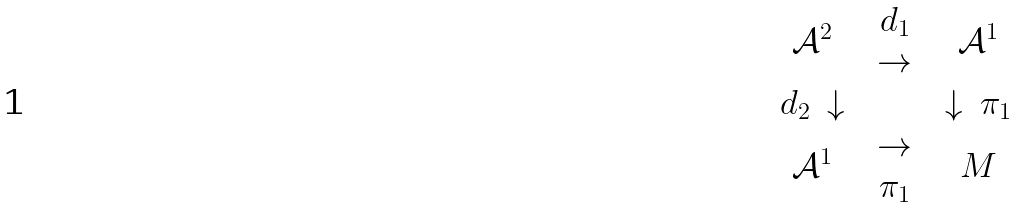Convert formula to latex. <formula><loc_0><loc_0><loc_500><loc_500>\begin{array} { c c c } \mathcal { A } ^ { 2 } & \begin{array} { c } d _ { 1 } \\ \rightarrow \end{array} & \mathcal { A } ^ { 1 } \\ \begin{array} { c c } d _ { 2 } & \downarrow \end{array} & & \begin{array} { c c } \downarrow & \pi _ { 1 } \end{array} \\ \mathcal { A } ^ { 1 } & \begin{array} { c } \rightarrow \\ \pi _ { 1 } \end{array} & M \end{array}</formula> 